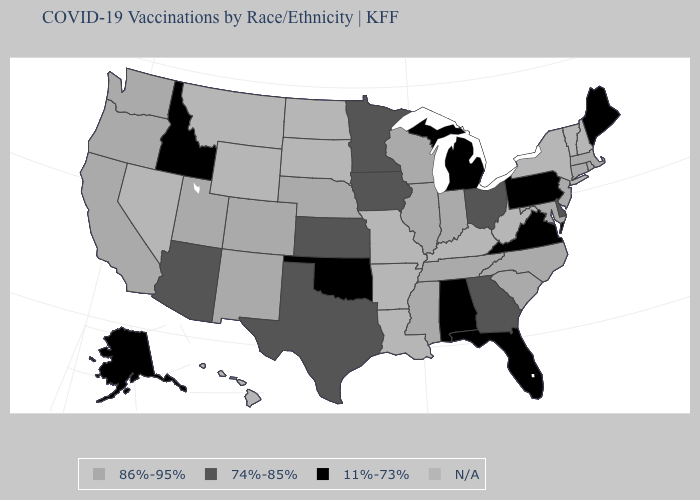Name the states that have a value in the range 11%-73%?
Concise answer only. Alabama, Alaska, Florida, Idaho, Maine, Michigan, Oklahoma, Pennsylvania, Virginia. What is the lowest value in states that border Maryland?
Be succinct. 11%-73%. What is the highest value in the USA?
Concise answer only. 86%-95%. Name the states that have a value in the range 86%-95%?
Answer briefly. California, Colorado, Connecticut, Illinois, Indiana, Maryland, Massachusetts, Mississippi, Nebraska, New Jersey, New Mexico, North Carolina, Oregon, Rhode Island, South Carolina, Tennessee, Utah, Washington, Wisconsin. Among the states that border Indiana , does Illinois have the highest value?
Quick response, please. Yes. What is the value of Delaware?
Keep it brief. 74%-85%. Does Tennessee have the highest value in the South?
Keep it brief. Yes. What is the value of California?
Keep it brief. 86%-95%. Among the states that border Oklahoma , does New Mexico have the lowest value?
Quick response, please. No. Name the states that have a value in the range N/A?
Keep it brief. Arkansas, Hawaii, Kentucky, Louisiana, Missouri, Montana, Nevada, New Hampshire, New York, North Dakota, South Dakota, Vermont, West Virginia, Wyoming. Name the states that have a value in the range 74%-85%?
Answer briefly. Arizona, Delaware, Georgia, Iowa, Kansas, Minnesota, Ohio, Texas. What is the lowest value in states that border Wyoming?
Short answer required. 11%-73%. Which states have the lowest value in the USA?
Give a very brief answer. Alabama, Alaska, Florida, Idaho, Maine, Michigan, Oklahoma, Pennsylvania, Virginia. 